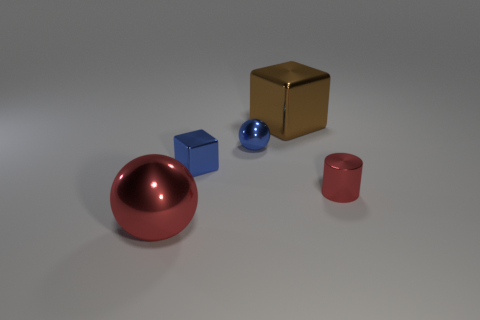There is a red metallic thing to the left of the big thing behind the tiny red metallic cylinder; what number of blue objects are in front of it?
Offer a very short reply. 0. There is a red object that is to the right of the large brown thing; how big is it?
Offer a very short reply. Small. What number of blue shiny things are the same size as the blue cube?
Keep it short and to the point. 1. There is a blue shiny ball; does it have the same size as the red cylinder in front of the tiny blue metal ball?
Make the answer very short. Yes. How many things are either blue blocks or cyan spheres?
Give a very brief answer. 1. What number of metallic spheres have the same color as the tiny cylinder?
Your answer should be compact. 1. The red object that is the same size as the brown thing is what shape?
Provide a short and direct response. Sphere. Are there any other objects of the same shape as the small red shiny thing?
Ensure brevity in your answer.  No. What number of small objects have the same material as the brown block?
Offer a terse response. 3. Are there more small shiny cylinders that are in front of the big red metal thing than blocks that are in front of the blue sphere?
Your answer should be very brief. No. 